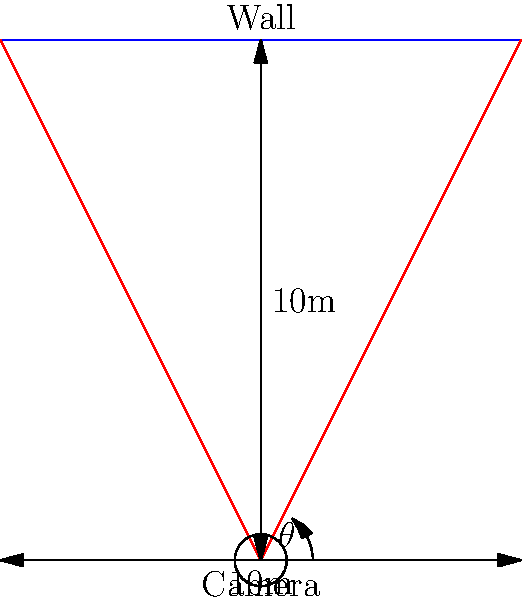As a software engineer developing tools for neighborhood watch efforts, you need to determine the field of view for a security camera. The camera is placed 10 meters away from a wall and needs to cover a 10-meter wide section of the wall. What should be the minimum horizontal field of view angle ($\theta$) of the camera lens to achieve this coverage? To solve this problem, we'll use basic trigonometry:

1. Visualize the scenario: The camera forms a triangle with the wall, where the camera is at the vertex and the wall forms the opposite side.

2. Identify the known values:
   - Distance from camera to wall: 10 meters
   - Width of wall to be covered: 10 meters

3. The field of view angle ($\theta$) is formed by two lines from the camera to the edges of the 10-meter section on the wall.

4. We can split this into two right triangles, each covering half of the wall width (5 meters).

5. In one of these right triangles:
   - Adjacent side = 10 meters (distance to wall)
   - Opposite side = 5 meters (half of wall width)

6. We can use the tangent function to find half of the angle $\theta$:

   $$\tan(\frac{\theta}{2}) = \frac{\text{opposite}}{\text{adjacent}} = \frac{5}{10} = 0.5$$

7. To find $\frac{\theta}{2}$, we use the inverse tangent (arctangent) function:

   $$\frac{\theta}{2} = \arctan(0.5) \approx 26.57°$$

8. The full angle $\theta$ is twice this value:

   $$\theta = 2 * 26.57° \approx 53.13°$$

Therefore, the minimum horizontal field of view angle should be approximately 53.13°.
Answer: 53.13° 